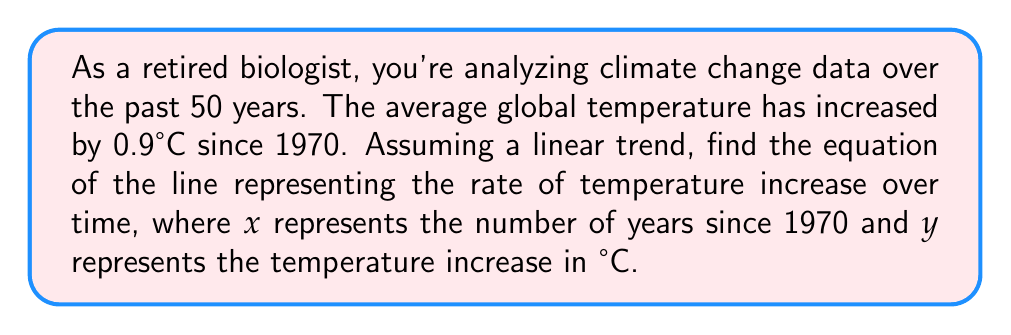Can you solve this math problem? Let's approach this step-by-step:

1) We know two points on this line:
   - In 1970 (x = 0), the temperature increase was 0°C (y = 0)
   - In 2020 (x = 50), the temperature increase was 0.9°C (y = 0.9)

2) We can use the point-slope form of a line: $y - y_1 = m(x - x_1)$

3) To find the slope (m), we use the formula:
   $m = \frac{y_2 - y_1}{x_2 - x_1} = \frac{0.9 - 0}{50 - 0} = \frac{0.9}{50} = 0.018$

4) This means the temperature is increasing by 0.018°C per year.

5) Now we can use either point to create our equation. Let's use (0, 0):
   $y - 0 = 0.018(x - 0)$

6) Simplify:
   $y = 0.018x$

This equation represents the linear trend of temperature increase over time since 1970.
Answer: $y = 0.018x$ 